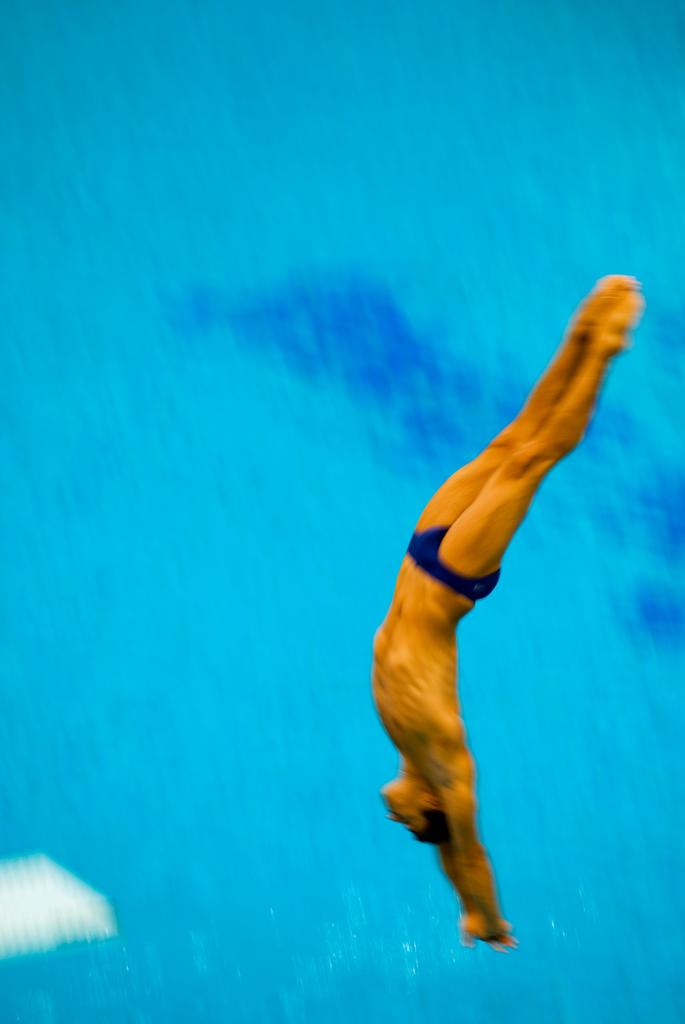What is the main subject of the image? There is a man in the image. What is the man doing in the image? The man is diving into the water. What type of produce is the man holding while diving in the image? There is no produce present in the image; the man is simply diving into the water. 